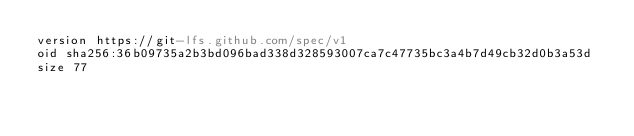Convert code to text. <code><loc_0><loc_0><loc_500><loc_500><_YAML_>version https://git-lfs.github.com/spec/v1
oid sha256:36b09735a2b3bd096bad338d328593007ca7c47735bc3a4b7d49cb32d0b3a53d
size 77
</code> 